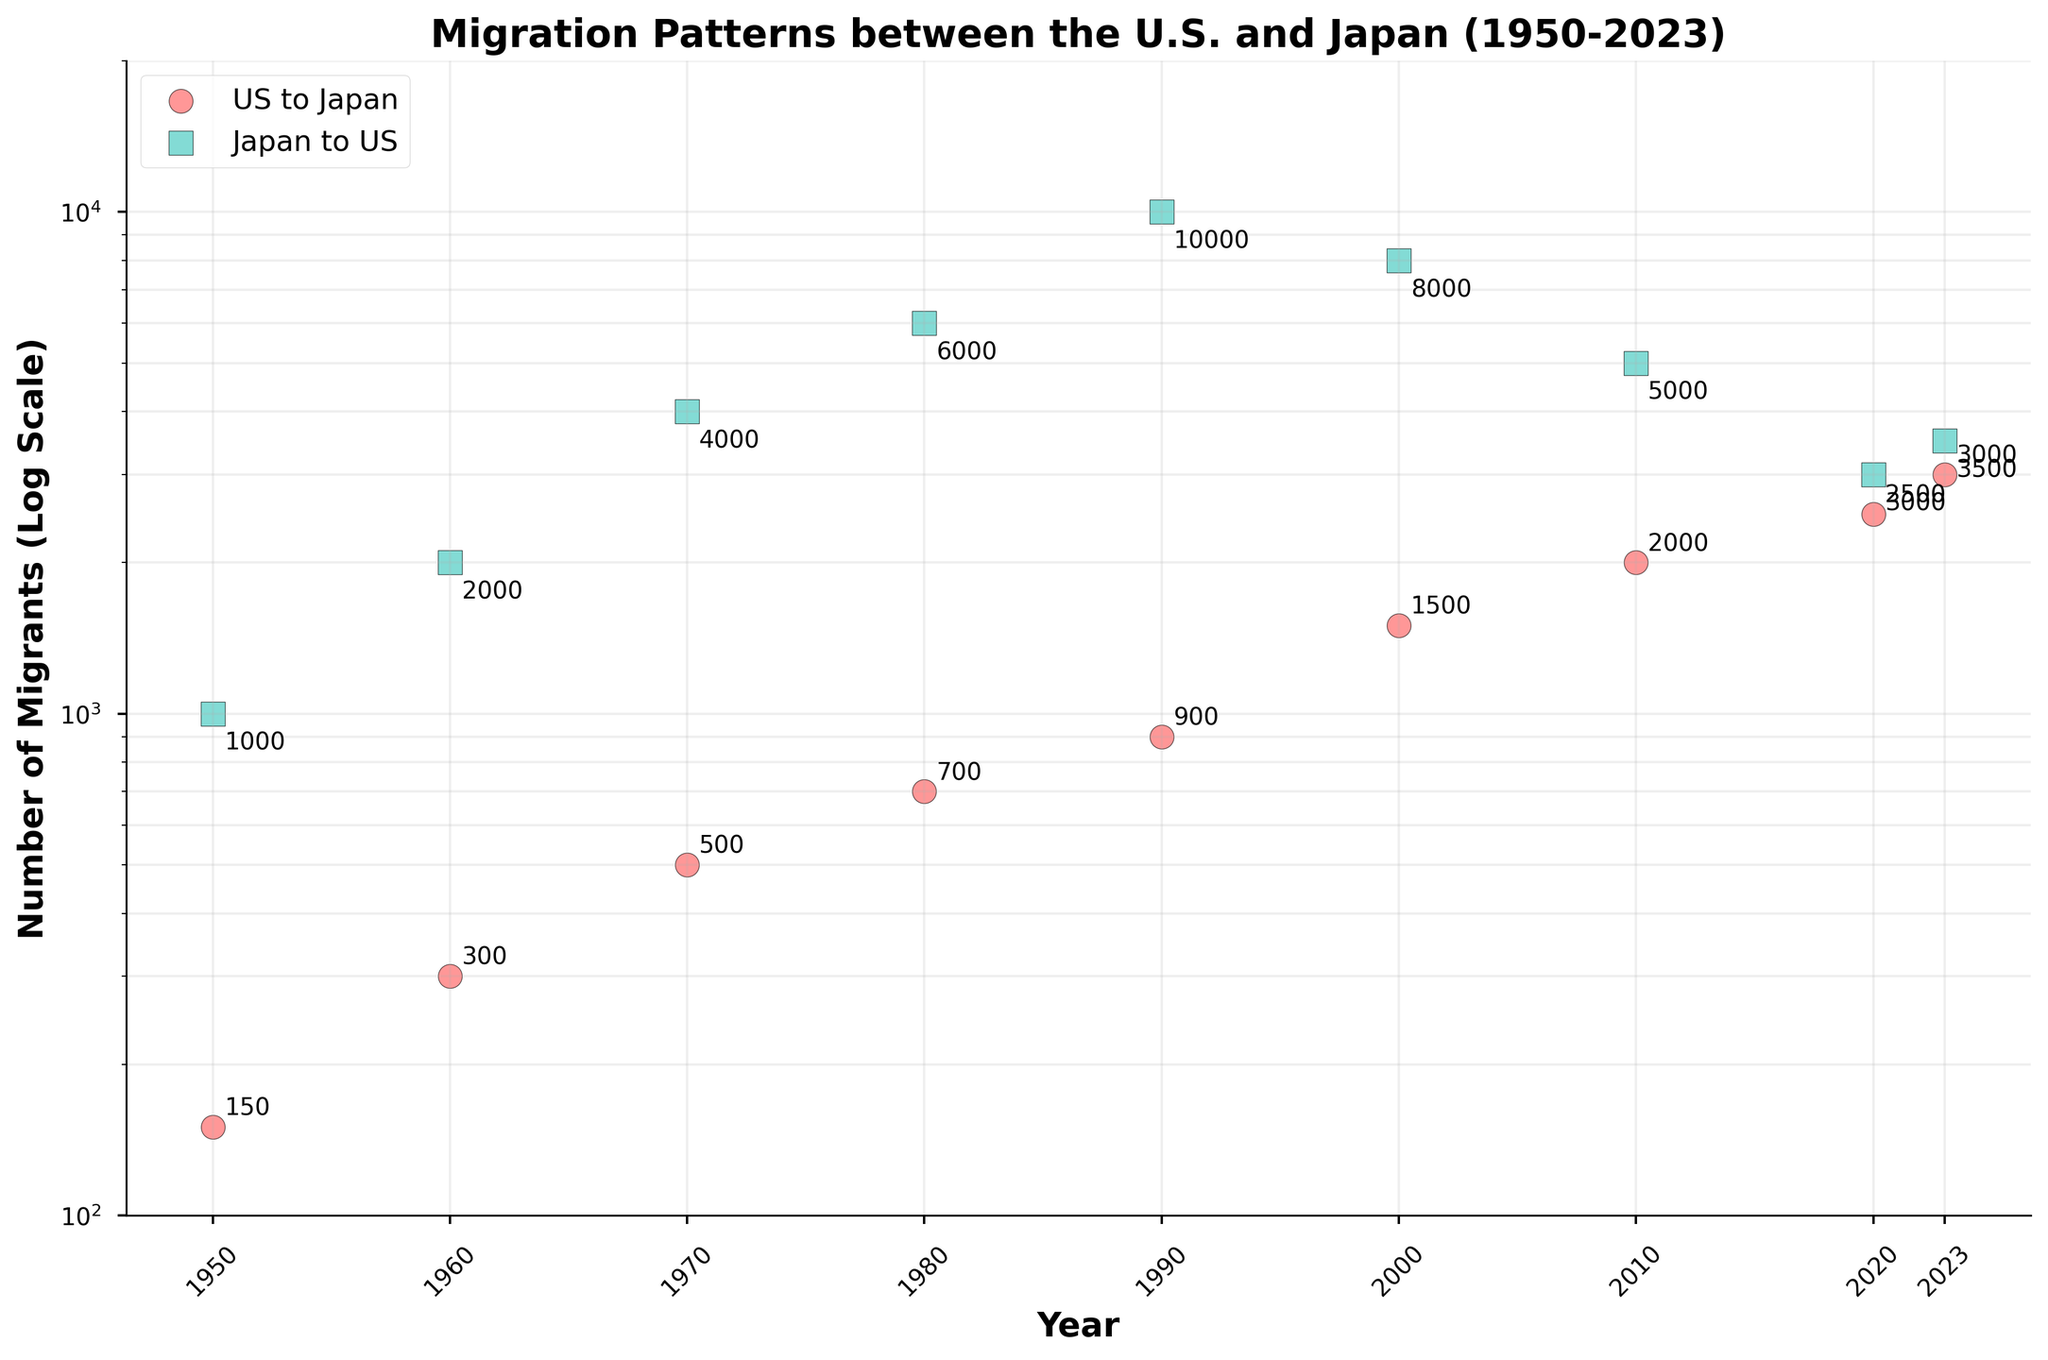What is the title of the figure? The title of the figure is located at the top and provides a summary of the visualized data. Here, it is clearly stated in bold.
Answer: Migration Patterns between the U.S. and Japan (1950-2023) How many migration patterns are shown in the figure? The figure shows two distinct migration patterns, represented by two different scatter plot markers. One is for migration from the U.S. to Japan, and the other is for migration from Japan to the U.S.
Answer: 2 What are the colors used to distinguish the two migration flows? The figure uses two different colors to differentiate between the migration flows. By looking at the legend, we can see that one color is used for U.S. to Japan and another for Japan to U.S.
Answer: Red and Teal How many data points are there for migration from the U.S. to Japan? Each data point represents the number of migrants in a specific year. By counting the data points for the red circles, we can determine the total number.
Answer: 9 What is the value of migration from Japan to the U.S. in the year 2000? By locating the year 2000 on the x-axis and finding the corresponding teal square, we can see the annotated value next to the marker.
Answer: 8000 Between which years did the migration from the U.S. to Japan first exceed 1000? By examining the y-axis in log scale and looking for when the red circles cross the 1000 mark, we can determine the specific year.
Answer: 1990 and 2000 What is the pattern for migration from Japan to the U.S. from 1950 to 2023? Observing the teal squares over the years, we see an initial rise, peaking around 1990, followed by a decline toward 2020 and a slight increase by 2023.
Answer: Rise, peak, decline, slight increase Which migration direction had a larger increase from 1970 to 1980? We need to compare the migration values for each direction in 1970 and 1980. Subtract the 1970 values from the 1980 values and compare the results.
Answer: Japan to the U.S What is the ratio of migration from the U.S. to Japan to migration from Japan to the U.S. in 2010? To get the ratio, divide the value of U.S. to Japan migrants by the value of Japan to U.S. migrants for the year 2010.
Answer: 0.4 (2000/5000) How did migration from Japan to the U.S. change between 2020 and 2023? To find the change, look at the values for 2020 and 2023 and subtract the 2020 value from the 2023 value. This will show the difference over these years.
Answer: Increased by 500 